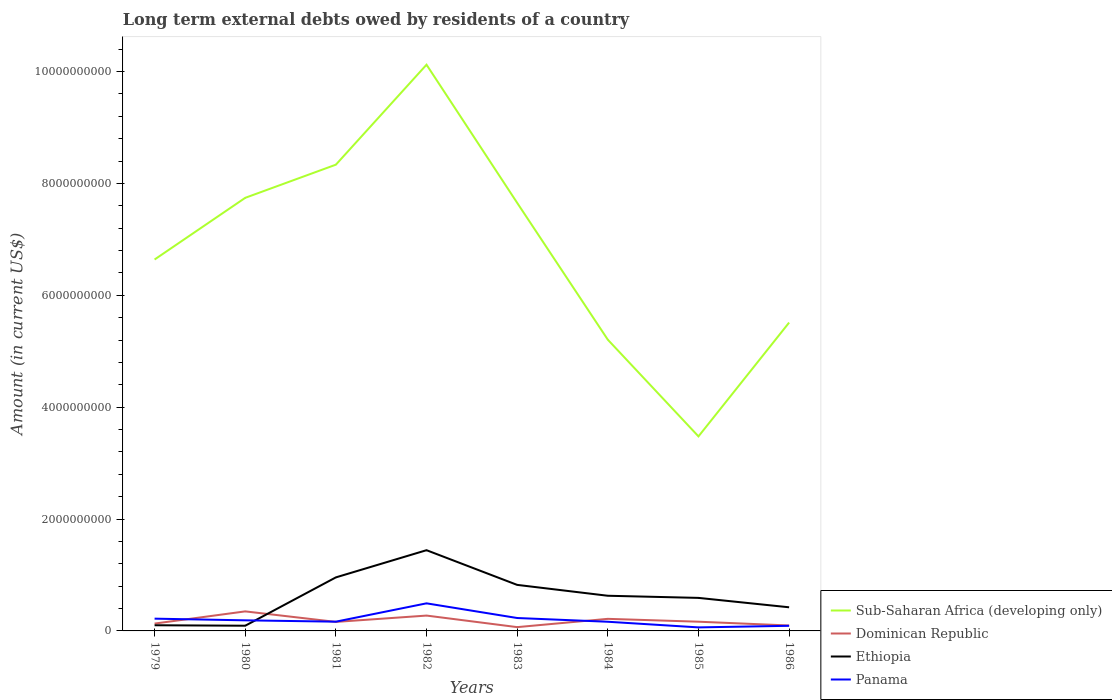Does the line corresponding to Dominican Republic intersect with the line corresponding to Sub-Saharan Africa (developing only)?
Offer a very short reply. No. Across all years, what is the maximum amount of long-term external debts owed by residents in Panama?
Your answer should be very brief. 6.31e+07. In which year was the amount of long-term external debts owed by residents in Dominican Republic maximum?
Offer a very short reply. 1983. What is the total amount of long-term external debts owed by residents in Dominican Republic in the graph?
Your response must be concise. 1.77e+08. What is the difference between the highest and the second highest amount of long-term external debts owed by residents in Sub-Saharan Africa (developing only)?
Keep it short and to the point. 6.64e+09. What is the difference between the highest and the lowest amount of long-term external debts owed by residents in Sub-Saharan Africa (developing only)?
Ensure brevity in your answer.  4. How many lines are there?
Offer a very short reply. 4. Does the graph contain any zero values?
Make the answer very short. No. Does the graph contain grids?
Your answer should be compact. No. How many legend labels are there?
Your response must be concise. 4. What is the title of the graph?
Your answer should be compact. Long term external debts owed by residents of a country. What is the Amount (in current US$) in Sub-Saharan Africa (developing only) in 1979?
Ensure brevity in your answer.  6.64e+09. What is the Amount (in current US$) in Dominican Republic in 1979?
Provide a succinct answer. 1.31e+08. What is the Amount (in current US$) in Ethiopia in 1979?
Ensure brevity in your answer.  1.01e+08. What is the Amount (in current US$) in Panama in 1979?
Offer a terse response. 2.19e+08. What is the Amount (in current US$) in Sub-Saharan Africa (developing only) in 1980?
Make the answer very short. 7.74e+09. What is the Amount (in current US$) of Dominican Republic in 1980?
Your response must be concise. 3.49e+08. What is the Amount (in current US$) of Ethiopia in 1980?
Keep it short and to the point. 9.30e+07. What is the Amount (in current US$) in Panama in 1980?
Your response must be concise. 1.89e+08. What is the Amount (in current US$) of Sub-Saharan Africa (developing only) in 1981?
Ensure brevity in your answer.  8.34e+09. What is the Amount (in current US$) in Dominican Republic in 1981?
Your answer should be compact. 1.61e+08. What is the Amount (in current US$) in Ethiopia in 1981?
Your answer should be compact. 9.57e+08. What is the Amount (in current US$) of Panama in 1981?
Your answer should be very brief. 1.65e+08. What is the Amount (in current US$) of Sub-Saharan Africa (developing only) in 1982?
Your response must be concise. 1.01e+1. What is the Amount (in current US$) in Dominican Republic in 1982?
Provide a succinct answer. 2.74e+08. What is the Amount (in current US$) of Ethiopia in 1982?
Make the answer very short. 1.44e+09. What is the Amount (in current US$) in Panama in 1982?
Offer a very short reply. 4.93e+08. What is the Amount (in current US$) of Sub-Saharan Africa (developing only) in 1983?
Offer a terse response. 7.65e+09. What is the Amount (in current US$) in Dominican Republic in 1983?
Provide a succinct answer. 6.77e+07. What is the Amount (in current US$) of Ethiopia in 1983?
Provide a short and direct response. 8.23e+08. What is the Amount (in current US$) of Panama in 1983?
Your response must be concise. 2.31e+08. What is the Amount (in current US$) in Sub-Saharan Africa (developing only) in 1984?
Offer a terse response. 5.21e+09. What is the Amount (in current US$) of Dominican Republic in 1984?
Give a very brief answer. 2.16e+08. What is the Amount (in current US$) in Ethiopia in 1984?
Your answer should be compact. 6.29e+08. What is the Amount (in current US$) in Panama in 1984?
Give a very brief answer. 1.64e+08. What is the Amount (in current US$) of Sub-Saharan Africa (developing only) in 1985?
Your answer should be compact. 3.48e+09. What is the Amount (in current US$) of Dominican Republic in 1985?
Provide a succinct answer. 1.65e+08. What is the Amount (in current US$) of Ethiopia in 1985?
Offer a very short reply. 5.91e+08. What is the Amount (in current US$) of Panama in 1985?
Provide a succinct answer. 6.31e+07. What is the Amount (in current US$) of Sub-Saharan Africa (developing only) in 1986?
Your answer should be compact. 5.51e+09. What is the Amount (in current US$) in Dominican Republic in 1986?
Provide a short and direct response. 9.71e+07. What is the Amount (in current US$) of Ethiopia in 1986?
Your response must be concise. 4.23e+08. What is the Amount (in current US$) in Panama in 1986?
Offer a terse response. 9.17e+07. Across all years, what is the maximum Amount (in current US$) of Sub-Saharan Africa (developing only)?
Make the answer very short. 1.01e+1. Across all years, what is the maximum Amount (in current US$) in Dominican Republic?
Ensure brevity in your answer.  3.49e+08. Across all years, what is the maximum Amount (in current US$) in Ethiopia?
Your answer should be compact. 1.44e+09. Across all years, what is the maximum Amount (in current US$) of Panama?
Ensure brevity in your answer.  4.93e+08. Across all years, what is the minimum Amount (in current US$) of Sub-Saharan Africa (developing only)?
Provide a succinct answer. 3.48e+09. Across all years, what is the minimum Amount (in current US$) in Dominican Republic?
Your answer should be very brief. 6.77e+07. Across all years, what is the minimum Amount (in current US$) of Ethiopia?
Offer a very short reply. 9.30e+07. Across all years, what is the minimum Amount (in current US$) of Panama?
Make the answer very short. 6.31e+07. What is the total Amount (in current US$) of Sub-Saharan Africa (developing only) in the graph?
Offer a terse response. 5.47e+1. What is the total Amount (in current US$) of Dominican Republic in the graph?
Ensure brevity in your answer.  1.46e+09. What is the total Amount (in current US$) in Ethiopia in the graph?
Offer a terse response. 5.06e+09. What is the total Amount (in current US$) of Panama in the graph?
Offer a terse response. 1.62e+09. What is the difference between the Amount (in current US$) of Sub-Saharan Africa (developing only) in 1979 and that in 1980?
Keep it short and to the point. -1.10e+09. What is the difference between the Amount (in current US$) of Dominican Republic in 1979 and that in 1980?
Ensure brevity in your answer.  -2.18e+08. What is the difference between the Amount (in current US$) of Ethiopia in 1979 and that in 1980?
Provide a succinct answer. 8.29e+06. What is the difference between the Amount (in current US$) in Panama in 1979 and that in 1980?
Ensure brevity in your answer.  3.00e+07. What is the difference between the Amount (in current US$) of Sub-Saharan Africa (developing only) in 1979 and that in 1981?
Provide a short and direct response. -1.70e+09. What is the difference between the Amount (in current US$) of Dominican Republic in 1979 and that in 1981?
Ensure brevity in your answer.  -3.00e+07. What is the difference between the Amount (in current US$) in Ethiopia in 1979 and that in 1981?
Make the answer very short. -8.56e+08. What is the difference between the Amount (in current US$) of Panama in 1979 and that in 1981?
Give a very brief answer. 5.39e+07. What is the difference between the Amount (in current US$) in Sub-Saharan Africa (developing only) in 1979 and that in 1982?
Offer a terse response. -3.48e+09. What is the difference between the Amount (in current US$) of Dominican Republic in 1979 and that in 1982?
Give a very brief answer. -1.43e+08. What is the difference between the Amount (in current US$) in Ethiopia in 1979 and that in 1982?
Your answer should be very brief. -1.34e+09. What is the difference between the Amount (in current US$) in Panama in 1979 and that in 1982?
Provide a succinct answer. -2.74e+08. What is the difference between the Amount (in current US$) of Sub-Saharan Africa (developing only) in 1979 and that in 1983?
Keep it short and to the point. -1.01e+09. What is the difference between the Amount (in current US$) in Dominican Republic in 1979 and that in 1983?
Give a very brief answer. 6.35e+07. What is the difference between the Amount (in current US$) in Ethiopia in 1979 and that in 1983?
Offer a terse response. -7.22e+08. What is the difference between the Amount (in current US$) of Panama in 1979 and that in 1983?
Provide a short and direct response. -1.15e+07. What is the difference between the Amount (in current US$) in Sub-Saharan Africa (developing only) in 1979 and that in 1984?
Your response must be concise. 1.43e+09. What is the difference between the Amount (in current US$) of Dominican Republic in 1979 and that in 1984?
Make the answer very short. -8.48e+07. What is the difference between the Amount (in current US$) of Ethiopia in 1979 and that in 1984?
Provide a short and direct response. -5.27e+08. What is the difference between the Amount (in current US$) of Panama in 1979 and that in 1984?
Keep it short and to the point. 5.54e+07. What is the difference between the Amount (in current US$) in Sub-Saharan Africa (developing only) in 1979 and that in 1985?
Your response must be concise. 3.16e+09. What is the difference between the Amount (in current US$) of Dominican Republic in 1979 and that in 1985?
Keep it short and to the point. -3.37e+07. What is the difference between the Amount (in current US$) of Ethiopia in 1979 and that in 1985?
Keep it short and to the point. -4.89e+08. What is the difference between the Amount (in current US$) of Panama in 1979 and that in 1985?
Ensure brevity in your answer.  1.56e+08. What is the difference between the Amount (in current US$) of Sub-Saharan Africa (developing only) in 1979 and that in 1986?
Offer a terse response. 1.13e+09. What is the difference between the Amount (in current US$) of Dominican Republic in 1979 and that in 1986?
Offer a very short reply. 3.41e+07. What is the difference between the Amount (in current US$) of Ethiopia in 1979 and that in 1986?
Keep it short and to the point. -3.21e+08. What is the difference between the Amount (in current US$) of Panama in 1979 and that in 1986?
Your answer should be very brief. 1.28e+08. What is the difference between the Amount (in current US$) in Sub-Saharan Africa (developing only) in 1980 and that in 1981?
Your response must be concise. -5.93e+08. What is the difference between the Amount (in current US$) of Dominican Republic in 1980 and that in 1981?
Offer a very short reply. 1.88e+08. What is the difference between the Amount (in current US$) in Ethiopia in 1980 and that in 1981?
Your response must be concise. -8.64e+08. What is the difference between the Amount (in current US$) in Panama in 1980 and that in 1981?
Provide a succinct answer. 2.39e+07. What is the difference between the Amount (in current US$) in Sub-Saharan Africa (developing only) in 1980 and that in 1982?
Your answer should be very brief. -2.38e+09. What is the difference between the Amount (in current US$) of Dominican Republic in 1980 and that in 1982?
Make the answer very short. 7.50e+07. What is the difference between the Amount (in current US$) of Ethiopia in 1980 and that in 1982?
Provide a short and direct response. -1.35e+09. What is the difference between the Amount (in current US$) of Panama in 1980 and that in 1982?
Your answer should be very brief. -3.04e+08. What is the difference between the Amount (in current US$) in Sub-Saharan Africa (developing only) in 1980 and that in 1983?
Your response must be concise. 8.99e+07. What is the difference between the Amount (in current US$) in Dominican Republic in 1980 and that in 1983?
Your answer should be very brief. 2.82e+08. What is the difference between the Amount (in current US$) of Ethiopia in 1980 and that in 1983?
Offer a terse response. -7.30e+08. What is the difference between the Amount (in current US$) in Panama in 1980 and that in 1983?
Offer a very short reply. -4.15e+07. What is the difference between the Amount (in current US$) of Sub-Saharan Africa (developing only) in 1980 and that in 1984?
Make the answer very short. 2.54e+09. What is the difference between the Amount (in current US$) in Dominican Republic in 1980 and that in 1984?
Offer a very short reply. 1.33e+08. What is the difference between the Amount (in current US$) in Ethiopia in 1980 and that in 1984?
Keep it short and to the point. -5.36e+08. What is the difference between the Amount (in current US$) of Panama in 1980 and that in 1984?
Offer a very short reply. 2.53e+07. What is the difference between the Amount (in current US$) in Sub-Saharan Africa (developing only) in 1980 and that in 1985?
Your response must be concise. 4.26e+09. What is the difference between the Amount (in current US$) of Dominican Republic in 1980 and that in 1985?
Your response must be concise. 1.84e+08. What is the difference between the Amount (in current US$) in Ethiopia in 1980 and that in 1985?
Ensure brevity in your answer.  -4.98e+08. What is the difference between the Amount (in current US$) in Panama in 1980 and that in 1985?
Provide a short and direct response. 1.26e+08. What is the difference between the Amount (in current US$) in Sub-Saharan Africa (developing only) in 1980 and that in 1986?
Offer a very short reply. 2.23e+09. What is the difference between the Amount (in current US$) of Dominican Republic in 1980 and that in 1986?
Offer a very short reply. 2.52e+08. What is the difference between the Amount (in current US$) of Ethiopia in 1980 and that in 1986?
Give a very brief answer. -3.30e+08. What is the difference between the Amount (in current US$) of Panama in 1980 and that in 1986?
Ensure brevity in your answer.  9.76e+07. What is the difference between the Amount (in current US$) in Sub-Saharan Africa (developing only) in 1981 and that in 1982?
Make the answer very short. -1.79e+09. What is the difference between the Amount (in current US$) of Dominican Republic in 1981 and that in 1982?
Give a very brief answer. -1.13e+08. What is the difference between the Amount (in current US$) of Ethiopia in 1981 and that in 1982?
Ensure brevity in your answer.  -4.86e+08. What is the difference between the Amount (in current US$) in Panama in 1981 and that in 1982?
Your answer should be compact. -3.28e+08. What is the difference between the Amount (in current US$) of Sub-Saharan Africa (developing only) in 1981 and that in 1983?
Make the answer very short. 6.83e+08. What is the difference between the Amount (in current US$) of Dominican Republic in 1981 and that in 1983?
Keep it short and to the point. 9.35e+07. What is the difference between the Amount (in current US$) in Ethiopia in 1981 and that in 1983?
Offer a very short reply. 1.34e+08. What is the difference between the Amount (in current US$) in Panama in 1981 and that in 1983?
Keep it short and to the point. -6.54e+07. What is the difference between the Amount (in current US$) of Sub-Saharan Africa (developing only) in 1981 and that in 1984?
Your response must be concise. 3.13e+09. What is the difference between the Amount (in current US$) in Dominican Republic in 1981 and that in 1984?
Offer a terse response. -5.48e+07. What is the difference between the Amount (in current US$) of Ethiopia in 1981 and that in 1984?
Make the answer very short. 3.28e+08. What is the difference between the Amount (in current US$) of Panama in 1981 and that in 1984?
Keep it short and to the point. 1.44e+06. What is the difference between the Amount (in current US$) in Sub-Saharan Africa (developing only) in 1981 and that in 1985?
Provide a short and direct response. 4.86e+09. What is the difference between the Amount (in current US$) of Dominican Republic in 1981 and that in 1985?
Keep it short and to the point. -3.71e+06. What is the difference between the Amount (in current US$) of Ethiopia in 1981 and that in 1985?
Your answer should be compact. 3.67e+08. What is the difference between the Amount (in current US$) of Panama in 1981 and that in 1985?
Your answer should be compact. 1.02e+08. What is the difference between the Amount (in current US$) of Sub-Saharan Africa (developing only) in 1981 and that in 1986?
Offer a terse response. 2.82e+09. What is the difference between the Amount (in current US$) in Dominican Republic in 1981 and that in 1986?
Provide a short and direct response. 6.41e+07. What is the difference between the Amount (in current US$) of Ethiopia in 1981 and that in 1986?
Give a very brief answer. 5.35e+08. What is the difference between the Amount (in current US$) in Panama in 1981 and that in 1986?
Your answer should be compact. 7.37e+07. What is the difference between the Amount (in current US$) of Sub-Saharan Africa (developing only) in 1982 and that in 1983?
Your answer should be compact. 2.47e+09. What is the difference between the Amount (in current US$) of Dominican Republic in 1982 and that in 1983?
Your answer should be very brief. 2.07e+08. What is the difference between the Amount (in current US$) in Ethiopia in 1982 and that in 1983?
Offer a terse response. 6.20e+08. What is the difference between the Amount (in current US$) in Panama in 1982 and that in 1983?
Provide a succinct answer. 2.62e+08. What is the difference between the Amount (in current US$) of Sub-Saharan Africa (developing only) in 1982 and that in 1984?
Make the answer very short. 4.92e+09. What is the difference between the Amount (in current US$) in Dominican Republic in 1982 and that in 1984?
Offer a very short reply. 5.84e+07. What is the difference between the Amount (in current US$) of Ethiopia in 1982 and that in 1984?
Provide a succinct answer. 8.14e+08. What is the difference between the Amount (in current US$) of Panama in 1982 and that in 1984?
Your answer should be compact. 3.29e+08. What is the difference between the Amount (in current US$) in Sub-Saharan Africa (developing only) in 1982 and that in 1985?
Offer a very short reply. 6.64e+09. What is the difference between the Amount (in current US$) of Dominican Republic in 1982 and that in 1985?
Ensure brevity in your answer.  1.09e+08. What is the difference between the Amount (in current US$) in Ethiopia in 1982 and that in 1985?
Provide a succinct answer. 8.53e+08. What is the difference between the Amount (in current US$) of Panama in 1982 and that in 1985?
Give a very brief answer. 4.30e+08. What is the difference between the Amount (in current US$) in Sub-Saharan Africa (developing only) in 1982 and that in 1986?
Your response must be concise. 4.61e+09. What is the difference between the Amount (in current US$) in Dominican Republic in 1982 and that in 1986?
Offer a very short reply. 1.77e+08. What is the difference between the Amount (in current US$) in Ethiopia in 1982 and that in 1986?
Provide a succinct answer. 1.02e+09. What is the difference between the Amount (in current US$) of Panama in 1982 and that in 1986?
Keep it short and to the point. 4.01e+08. What is the difference between the Amount (in current US$) in Sub-Saharan Africa (developing only) in 1983 and that in 1984?
Offer a very short reply. 2.45e+09. What is the difference between the Amount (in current US$) in Dominican Republic in 1983 and that in 1984?
Ensure brevity in your answer.  -1.48e+08. What is the difference between the Amount (in current US$) in Ethiopia in 1983 and that in 1984?
Offer a terse response. 1.94e+08. What is the difference between the Amount (in current US$) in Panama in 1983 and that in 1984?
Ensure brevity in your answer.  6.69e+07. What is the difference between the Amount (in current US$) in Sub-Saharan Africa (developing only) in 1983 and that in 1985?
Make the answer very short. 4.17e+09. What is the difference between the Amount (in current US$) of Dominican Republic in 1983 and that in 1985?
Offer a terse response. -9.72e+07. What is the difference between the Amount (in current US$) in Ethiopia in 1983 and that in 1985?
Provide a succinct answer. 2.32e+08. What is the difference between the Amount (in current US$) in Panama in 1983 and that in 1985?
Your response must be concise. 1.68e+08. What is the difference between the Amount (in current US$) of Sub-Saharan Africa (developing only) in 1983 and that in 1986?
Offer a terse response. 2.14e+09. What is the difference between the Amount (in current US$) in Dominican Republic in 1983 and that in 1986?
Your response must be concise. -2.94e+07. What is the difference between the Amount (in current US$) of Ethiopia in 1983 and that in 1986?
Keep it short and to the point. 4.00e+08. What is the difference between the Amount (in current US$) of Panama in 1983 and that in 1986?
Make the answer very short. 1.39e+08. What is the difference between the Amount (in current US$) in Sub-Saharan Africa (developing only) in 1984 and that in 1985?
Your answer should be compact. 1.73e+09. What is the difference between the Amount (in current US$) of Dominican Republic in 1984 and that in 1985?
Your response must be concise. 5.11e+07. What is the difference between the Amount (in current US$) in Ethiopia in 1984 and that in 1985?
Your answer should be compact. 3.82e+07. What is the difference between the Amount (in current US$) in Panama in 1984 and that in 1985?
Offer a terse response. 1.01e+08. What is the difference between the Amount (in current US$) in Sub-Saharan Africa (developing only) in 1984 and that in 1986?
Provide a succinct answer. -3.06e+08. What is the difference between the Amount (in current US$) in Dominican Republic in 1984 and that in 1986?
Offer a terse response. 1.19e+08. What is the difference between the Amount (in current US$) of Ethiopia in 1984 and that in 1986?
Your answer should be compact. 2.06e+08. What is the difference between the Amount (in current US$) of Panama in 1984 and that in 1986?
Your answer should be very brief. 7.23e+07. What is the difference between the Amount (in current US$) of Sub-Saharan Africa (developing only) in 1985 and that in 1986?
Offer a very short reply. -2.03e+09. What is the difference between the Amount (in current US$) of Dominican Republic in 1985 and that in 1986?
Keep it short and to the point. 6.78e+07. What is the difference between the Amount (in current US$) in Ethiopia in 1985 and that in 1986?
Make the answer very short. 1.68e+08. What is the difference between the Amount (in current US$) of Panama in 1985 and that in 1986?
Offer a very short reply. -2.86e+07. What is the difference between the Amount (in current US$) of Sub-Saharan Africa (developing only) in 1979 and the Amount (in current US$) of Dominican Republic in 1980?
Offer a terse response. 6.29e+09. What is the difference between the Amount (in current US$) of Sub-Saharan Africa (developing only) in 1979 and the Amount (in current US$) of Ethiopia in 1980?
Your answer should be compact. 6.55e+09. What is the difference between the Amount (in current US$) in Sub-Saharan Africa (developing only) in 1979 and the Amount (in current US$) in Panama in 1980?
Make the answer very short. 6.45e+09. What is the difference between the Amount (in current US$) in Dominican Republic in 1979 and the Amount (in current US$) in Ethiopia in 1980?
Your response must be concise. 3.82e+07. What is the difference between the Amount (in current US$) of Dominican Republic in 1979 and the Amount (in current US$) of Panama in 1980?
Ensure brevity in your answer.  -5.81e+07. What is the difference between the Amount (in current US$) in Ethiopia in 1979 and the Amount (in current US$) in Panama in 1980?
Provide a succinct answer. -8.80e+07. What is the difference between the Amount (in current US$) in Sub-Saharan Africa (developing only) in 1979 and the Amount (in current US$) in Dominican Republic in 1981?
Provide a succinct answer. 6.48e+09. What is the difference between the Amount (in current US$) in Sub-Saharan Africa (developing only) in 1979 and the Amount (in current US$) in Ethiopia in 1981?
Your answer should be very brief. 5.68e+09. What is the difference between the Amount (in current US$) in Sub-Saharan Africa (developing only) in 1979 and the Amount (in current US$) in Panama in 1981?
Give a very brief answer. 6.47e+09. What is the difference between the Amount (in current US$) in Dominican Republic in 1979 and the Amount (in current US$) in Ethiopia in 1981?
Give a very brief answer. -8.26e+08. What is the difference between the Amount (in current US$) in Dominican Republic in 1979 and the Amount (in current US$) in Panama in 1981?
Offer a very short reply. -3.42e+07. What is the difference between the Amount (in current US$) of Ethiopia in 1979 and the Amount (in current US$) of Panama in 1981?
Make the answer very short. -6.41e+07. What is the difference between the Amount (in current US$) in Sub-Saharan Africa (developing only) in 1979 and the Amount (in current US$) in Dominican Republic in 1982?
Your answer should be compact. 6.37e+09. What is the difference between the Amount (in current US$) of Sub-Saharan Africa (developing only) in 1979 and the Amount (in current US$) of Ethiopia in 1982?
Your response must be concise. 5.20e+09. What is the difference between the Amount (in current US$) in Sub-Saharan Africa (developing only) in 1979 and the Amount (in current US$) in Panama in 1982?
Offer a terse response. 6.15e+09. What is the difference between the Amount (in current US$) of Dominican Republic in 1979 and the Amount (in current US$) of Ethiopia in 1982?
Offer a terse response. -1.31e+09. What is the difference between the Amount (in current US$) in Dominican Republic in 1979 and the Amount (in current US$) in Panama in 1982?
Provide a succinct answer. -3.62e+08. What is the difference between the Amount (in current US$) in Ethiopia in 1979 and the Amount (in current US$) in Panama in 1982?
Give a very brief answer. -3.92e+08. What is the difference between the Amount (in current US$) in Sub-Saharan Africa (developing only) in 1979 and the Amount (in current US$) in Dominican Republic in 1983?
Offer a very short reply. 6.57e+09. What is the difference between the Amount (in current US$) of Sub-Saharan Africa (developing only) in 1979 and the Amount (in current US$) of Ethiopia in 1983?
Your answer should be compact. 5.82e+09. What is the difference between the Amount (in current US$) in Sub-Saharan Africa (developing only) in 1979 and the Amount (in current US$) in Panama in 1983?
Provide a succinct answer. 6.41e+09. What is the difference between the Amount (in current US$) in Dominican Republic in 1979 and the Amount (in current US$) in Ethiopia in 1983?
Keep it short and to the point. -6.92e+08. What is the difference between the Amount (in current US$) in Dominican Republic in 1979 and the Amount (in current US$) in Panama in 1983?
Offer a very short reply. -9.96e+07. What is the difference between the Amount (in current US$) of Ethiopia in 1979 and the Amount (in current US$) of Panama in 1983?
Your answer should be compact. -1.30e+08. What is the difference between the Amount (in current US$) of Sub-Saharan Africa (developing only) in 1979 and the Amount (in current US$) of Dominican Republic in 1984?
Your answer should be very brief. 6.42e+09. What is the difference between the Amount (in current US$) of Sub-Saharan Africa (developing only) in 1979 and the Amount (in current US$) of Ethiopia in 1984?
Provide a short and direct response. 6.01e+09. What is the difference between the Amount (in current US$) in Sub-Saharan Africa (developing only) in 1979 and the Amount (in current US$) in Panama in 1984?
Offer a very short reply. 6.48e+09. What is the difference between the Amount (in current US$) in Dominican Republic in 1979 and the Amount (in current US$) in Ethiopia in 1984?
Your answer should be very brief. -4.98e+08. What is the difference between the Amount (in current US$) of Dominican Republic in 1979 and the Amount (in current US$) of Panama in 1984?
Keep it short and to the point. -3.28e+07. What is the difference between the Amount (in current US$) of Ethiopia in 1979 and the Amount (in current US$) of Panama in 1984?
Provide a succinct answer. -6.27e+07. What is the difference between the Amount (in current US$) of Sub-Saharan Africa (developing only) in 1979 and the Amount (in current US$) of Dominican Republic in 1985?
Give a very brief answer. 6.48e+09. What is the difference between the Amount (in current US$) in Sub-Saharan Africa (developing only) in 1979 and the Amount (in current US$) in Ethiopia in 1985?
Provide a short and direct response. 6.05e+09. What is the difference between the Amount (in current US$) of Sub-Saharan Africa (developing only) in 1979 and the Amount (in current US$) of Panama in 1985?
Provide a succinct answer. 6.58e+09. What is the difference between the Amount (in current US$) of Dominican Republic in 1979 and the Amount (in current US$) of Ethiopia in 1985?
Your response must be concise. -4.59e+08. What is the difference between the Amount (in current US$) of Dominican Republic in 1979 and the Amount (in current US$) of Panama in 1985?
Make the answer very short. 6.81e+07. What is the difference between the Amount (in current US$) of Ethiopia in 1979 and the Amount (in current US$) of Panama in 1985?
Offer a very short reply. 3.82e+07. What is the difference between the Amount (in current US$) of Sub-Saharan Africa (developing only) in 1979 and the Amount (in current US$) of Dominican Republic in 1986?
Offer a terse response. 6.54e+09. What is the difference between the Amount (in current US$) of Sub-Saharan Africa (developing only) in 1979 and the Amount (in current US$) of Ethiopia in 1986?
Offer a very short reply. 6.22e+09. What is the difference between the Amount (in current US$) of Sub-Saharan Africa (developing only) in 1979 and the Amount (in current US$) of Panama in 1986?
Your answer should be compact. 6.55e+09. What is the difference between the Amount (in current US$) in Dominican Republic in 1979 and the Amount (in current US$) in Ethiopia in 1986?
Make the answer very short. -2.91e+08. What is the difference between the Amount (in current US$) of Dominican Republic in 1979 and the Amount (in current US$) of Panama in 1986?
Your response must be concise. 3.95e+07. What is the difference between the Amount (in current US$) in Ethiopia in 1979 and the Amount (in current US$) in Panama in 1986?
Provide a succinct answer. 9.62e+06. What is the difference between the Amount (in current US$) in Sub-Saharan Africa (developing only) in 1980 and the Amount (in current US$) in Dominican Republic in 1981?
Make the answer very short. 7.58e+09. What is the difference between the Amount (in current US$) of Sub-Saharan Africa (developing only) in 1980 and the Amount (in current US$) of Ethiopia in 1981?
Give a very brief answer. 6.79e+09. What is the difference between the Amount (in current US$) of Sub-Saharan Africa (developing only) in 1980 and the Amount (in current US$) of Panama in 1981?
Offer a very short reply. 7.58e+09. What is the difference between the Amount (in current US$) in Dominican Republic in 1980 and the Amount (in current US$) in Ethiopia in 1981?
Your answer should be very brief. -6.08e+08. What is the difference between the Amount (in current US$) in Dominican Republic in 1980 and the Amount (in current US$) in Panama in 1981?
Make the answer very short. 1.84e+08. What is the difference between the Amount (in current US$) in Ethiopia in 1980 and the Amount (in current US$) in Panama in 1981?
Ensure brevity in your answer.  -7.24e+07. What is the difference between the Amount (in current US$) of Sub-Saharan Africa (developing only) in 1980 and the Amount (in current US$) of Dominican Republic in 1982?
Your answer should be very brief. 7.47e+09. What is the difference between the Amount (in current US$) of Sub-Saharan Africa (developing only) in 1980 and the Amount (in current US$) of Ethiopia in 1982?
Offer a terse response. 6.30e+09. What is the difference between the Amount (in current US$) in Sub-Saharan Africa (developing only) in 1980 and the Amount (in current US$) in Panama in 1982?
Provide a short and direct response. 7.25e+09. What is the difference between the Amount (in current US$) in Dominican Republic in 1980 and the Amount (in current US$) in Ethiopia in 1982?
Make the answer very short. -1.09e+09. What is the difference between the Amount (in current US$) of Dominican Republic in 1980 and the Amount (in current US$) of Panama in 1982?
Keep it short and to the point. -1.44e+08. What is the difference between the Amount (in current US$) in Ethiopia in 1980 and the Amount (in current US$) in Panama in 1982?
Keep it short and to the point. -4.00e+08. What is the difference between the Amount (in current US$) of Sub-Saharan Africa (developing only) in 1980 and the Amount (in current US$) of Dominican Republic in 1983?
Give a very brief answer. 7.68e+09. What is the difference between the Amount (in current US$) in Sub-Saharan Africa (developing only) in 1980 and the Amount (in current US$) in Ethiopia in 1983?
Offer a very short reply. 6.92e+09. What is the difference between the Amount (in current US$) of Sub-Saharan Africa (developing only) in 1980 and the Amount (in current US$) of Panama in 1983?
Your response must be concise. 7.51e+09. What is the difference between the Amount (in current US$) in Dominican Republic in 1980 and the Amount (in current US$) in Ethiopia in 1983?
Offer a very short reply. -4.74e+08. What is the difference between the Amount (in current US$) of Dominican Republic in 1980 and the Amount (in current US$) of Panama in 1983?
Your answer should be very brief. 1.19e+08. What is the difference between the Amount (in current US$) in Ethiopia in 1980 and the Amount (in current US$) in Panama in 1983?
Your response must be concise. -1.38e+08. What is the difference between the Amount (in current US$) of Sub-Saharan Africa (developing only) in 1980 and the Amount (in current US$) of Dominican Republic in 1984?
Offer a terse response. 7.53e+09. What is the difference between the Amount (in current US$) in Sub-Saharan Africa (developing only) in 1980 and the Amount (in current US$) in Ethiopia in 1984?
Offer a very short reply. 7.11e+09. What is the difference between the Amount (in current US$) of Sub-Saharan Africa (developing only) in 1980 and the Amount (in current US$) of Panama in 1984?
Your answer should be very brief. 7.58e+09. What is the difference between the Amount (in current US$) in Dominican Republic in 1980 and the Amount (in current US$) in Ethiopia in 1984?
Your response must be concise. -2.79e+08. What is the difference between the Amount (in current US$) in Dominican Republic in 1980 and the Amount (in current US$) in Panama in 1984?
Ensure brevity in your answer.  1.85e+08. What is the difference between the Amount (in current US$) in Ethiopia in 1980 and the Amount (in current US$) in Panama in 1984?
Provide a short and direct response. -7.10e+07. What is the difference between the Amount (in current US$) of Sub-Saharan Africa (developing only) in 1980 and the Amount (in current US$) of Dominican Republic in 1985?
Ensure brevity in your answer.  7.58e+09. What is the difference between the Amount (in current US$) in Sub-Saharan Africa (developing only) in 1980 and the Amount (in current US$) in Ethiopia in 1985?
Provide a short and direct response. 7.15e+09. What is the difference between the Amount (in current US$) of Sub-Saharan Africa (developing only) in 1980 and the Amount (in current US$) of Panama in 1985?
Offer a very short reply. 7.68e+09. What is the difference between the Amount (in current US$) of Dominican Republic in 1980 and the Amount (in current US$) of Ethiopia in 1985?
Provide a short and direct response. -2.41e+08. What is the difference between the Amount (in current US$) of Dominican Republic in 1980 and the Amount (in current US$) of Panama in 1985?
Your answer should be very brief. 2.86e+08. What is the difference between the Amount (in current US$) in Ethiopia in 1980 and the Amount (in current US$) in Panama in 1985?
Keep it short and to the point. 2.99e+07. What is the difference between the Amount (in current US$) of Sub-Saharan Africa (developing only) in 1980 and the Amount (in current US$) of Dominican Republic in 1986?
Keep it short and to the point. 7.65e+09. What is the difference between the Amount (in current US$) in Sub-Saharan Africa (developing only) in 1980 and the Amount (in current US$) in Ethiopia in 1986?
Make the answer very short. 7.32e+09. What is the difference between the Amount (in current US$) of Sub-Saharan Africa (developing only) in 1980 and the Amount (in current US$) of Panama in 1986?
Your response must be concise. 7.65e+09. What is the difference between the Amount (in current US$) in Dominican Republic in 1980 and the Amount (in current US$) in Ethiopia in 1986?
Ensure brevity in your answer.  -7.32e+07. What is the difference between the Amount (in current US$) of Dominican Republic in 1980 and the Amount (in current US$) of Panama in 1986?
Your answer should be very brief. 2.58e+08. What is the difference between the Amount (in current US$) of Ethiopia in 1980 and the Amount (in current US$) of Panama in 1986?
Your answer should be very brief. 1.33e+06. What is the difference between the Amount (in current US$) in Sub-Saharan Africa (developing only) in 1981 and the Amount (in current US$) in Dominican Republic in 1982?
Offer a very short reply. 8.06e+09. What is the difference between the Amount (in current US$) of Sub-Saharan Africa (developing only) in 1981 and the Amount (in current US$) of Ethiopia in 1982?
Give a very brief answer. 6.89e+09. What is the difference between the Amount (in current US$) of Sub-Saharan Africa (developing only) in 1981 and the Amount (in current US$) of Panama in 1982?
Keep it short and to the point. 7.84e+09. What is the difference between the Amount (in current US$) in Dominican Republic in 1981 and the Amount (in current US$) in Ethiopia in 1982?
Give a very brief answer. -1.28e+09. What is the difference between the Amount (in current US$) in Dominican Republic in 1981 and the Amount (in current US$) in Panama in 1982?
Make the answer very short. -3.32e+08. What is the difference between the Amount (in current US$) in Ethiopia in 1981 and the Amount (in current US$) in Panama in 1982?
Offer a very short reply. 4.64e+08. What is the difference between the Amount (in current US$) of Sub-Saharan Africa (developing only) in 1981 and the Amount (in current US$) of Dominican Republic in 1983?
Give a very brief answer. 8.27e+09. What is the difference between the Amount (in current US$) in Sub-Saharan Africa (developing only) in 1981 and the Amount (in current US$) in Ethiopia in 1983?
Make the answer very short. 7.51e+09. What is the difference between the Amount (in current US$) of Sub-Saharan Africa (developing only) in 1981 and the Amount (in current US$) of Panama in 1983?
Provide a short and direct response. 8.10e+09. What is the difference between the Amount (in current US$) of Dominican Republic in 1981 and the Amount (in current US$) of Ethiopia in 1983?
Provide a succinct answer. -6.62e+08. What is the difference between the Amount (in current US$) of Dominican Republic in 1981 and the Amount (in current US$) of Panama in 1983?
Your response must be concise. -6.96e+07. What is the difference between the Amount (in current US$) in Ethiopia in 1981 and the Amount (in current US$) in Panama in 1983?
Your answer should be compact. 7.26e+08. What is the difference between the Amount (in current US$) in Sub-Saharan Africa (developing only) in 1981 and the Amount (in current US$) in Dominican Republic in 1984?
Keep it short and to the point. 8.12e+09. What is the difference between the Amount (in current US$) in Sub-Saharan Africa (developing only) in 1981 and the Amount (in current US$) in Ethiopia in 1984?
Make the answer very short. 7.71e+09. What is the difference between the Amount (in current US$) of Sub-Saharan Africa (developing only) in 1981 and the Amount (in current US$) of Panama in 1984?
Provide a succinct answer. 8.17e+09. What is the difference between the Amount (in current US$) in Dominican Republic in 1981 and the Amount (in current US$) in Ethiopia in 1984?
Offer a terse response. -4.68e+08. What is the difference between the Amount (in current US$) in Dominican Republic in 1981 and the Amount (in current US$) in Panama in 1984?
Provide a succinct answer. -2.75e+06. What is the difference between the Amount (in current US$) in Ethiopia in 1981 and the Amount (in current US$) in Panama in 1984?
Your response must be concise. 7.93e+08. What is the difference between the Amount (in current US$) in Sub-Saharan Africa (developing only) in 1981 and the Amount (in current US$) in Dominican Republic in 1985?
Offer a terse response. 8.17e+09. What is the difference between the Amount (in current US$) of Sub-Saharan Africa (developing only) in 1981 and the Amount (in current US$) of Ethiopia in 1985?
Make the answer very short. 7.74e+09. What is the difference between the Amount (in current US$) in Sub-Saharan Africa (developing only) in 1981 and the Amount (in current US$) in Panama in 1985?
Ensure brevity in your answer.  8.27e+09. What is the difference between the Amount (in current US$) in Dominican Republic in 1981 and the Amount (in current US$) in Ethiopia in 1985?
Offer a terse response. -4.29e+08. What is the difference between the Amount (in current US$) of Dominican Republic in 1981 and the Amount (in current US$) of Panama in 1985?
Keep it short and to the point. 9.81e+07. What is the difference between the Amount (in current US$) in Ethiopia in 1981 and the Amount (in current US$) in Panama in 1985?
Offer a terse response. 8.94e+08. What is the difference between the Amount (in current US$) in Sub-Saharan Africa (developing only) in 1981 and the Amount (in current US$) in Dominican Republic in 1986?
Your answer should be compact. 8.24e+09. What is the difference between the Amount (in current US$) in Sub-Saharan Africa (developing only) in 1981 and the Amount (in current US$) in Ethiopia in 1986?
Provide a succinct answer. 7.91e+09. What is the difference between the Amount (in current US$) in Sub-Saharan Africa (developing only) in 1981 and the Amount (in current US$) in Panama in 1986?
Ensure brevity in your answer.  8.24e+09. What is the difference between the Amount (in current US$) of Dominican Republic in 1981 and the Amount (in current US$) of Ethiopia in 1986?
Make the answer very short. -2.61e+08. What is the difference between the Amount (in current US$) of Dominican Republic in 1981 and the Amount (in current US$) of Panama in 1986?
Offer a terse response. 6.96e+07. What is the difference between the Amount (in current US$) of Ethiopia in 1981 and the Amount (in current US$) of Panama in 1986?
Keep it short and to the point. 8.65e+08. What is the difference between the Amount (in current US$) of Sub-Saharan Africa (developing only) in 1982 and the Amount (in current US$) of Dominican Republic in 1983?
Provide a short and direct response. 1.01e+1. What is the difference between the Amount (in current US$) in Sub-Saharan Africa (developing only) in 1982 and the Amount (in current US$) in Ethiopia in 1983?
Offer a terse response. 9.30e+09. What is the difference between the Amount (in current US$) of Sub-Saharan Africa (developing only) in 1982 and the Amount (in current US$) of Panama in 1983?
Your response must be concise. 9.89e+09. What is the difference between the Amount (in current US$) in Dominican Republic in 1982 and the Amount (in current US$) in Ethiopia in 1983?
Keep it short and to the point. -5.49e+08. What is the difference between the Amount (in current US$) of Dominican Republic in 1982 and the Amount (in current US$) of Panama in 1983?
Offer a very short reply. 4.36e+07. What is the difference between the Amount (in current US$) in Ethiopia in 1982 and the Amount (in current US$) in Panama in 1983?
Give a very brief answer. 1.21e+09. What is the difference between the Amount (in current US$) in Sub-Saharan Africa (developing only) in 1982 and the Amount (in current US$) in Dominican Republic in 1984?
Provide a succinct answer. 9.91e+09. What is the difference between the Amount (in current US$) in Sub-Saharan Africa (developing only) in 1982 and the Amount (in current US$) in Ethiopia in 1984?
Ensure brevity in your answer.  9.49e+09. What is the difference between the Amount (in current US$) of Sub-Saharan Africa (developing only) in 1982 and the Amount (in current US$) of Panama in 1984?
Provide a succinct answer. 9.96e+09. What is the difference between the Amount (in current US$) in Dominican Republic in 1982 and the Amount (in current US$) in Ethiopia in 1984?
Offer a very short reply. -3.54e+08. What is the difference between the Amount (in current US$) in Dominican Republic in 1982 and the Amount (in current US$) in Panama in 1984?
Provide a short and direct response. 1.10e+08. What is the difference between the Amount (in current US$) of Ethiopia in 1982 and the Amount (in current US$) of Panama in 1984?
Provide a succinct answer. 1.28e+09. What is the difference between the Amount (in current US$) in Sub-Saharan Africa (developing only) in 1982 and the Amount (in current US$) in Dominican Republic in 1985?
Provide a short and direct response. 9.96e+09. What is the difference between the Amount (in current US$) in Sub-Saharan Africa (developing only) in 1982 and the Amount (in current US$) in Ethiopia in 1985?
Ensure brevity in your answer.  9.53e+09. What is the difference between the Amount (in current US$) in Sub-Saharan Africa (developing only) in 1982 and the Amount (in current US$) in Panama in 1985?
Ensure brevity in your answer.  1.01e+1. What is the difference between the Amount (in current US$) of Dominican Republic in 1982 and the Amount (in current US$) of Ethiopia in 1985?
Your response must be concise. -3.16e+08. What is the difference between the Amount (in current US$) in Dominican Republic in 1982 and the Amount (in current US$) in Panama in 1985?
Offer a terse response. 2.11e+08. What is the difference between the Amount (in current US$) in Ethiopia in 1982 and the Amount (in current US$) in Panama in 1985?
Keep it short and to the point. 1.38e+09. What is the difference between the Amount (in current US$) of Sub-Saharan Africa (developing only) in 1982 and the Amount (in current US$) of Dominican Republic in 1986?
Ensure brevity in your answer.  1.00e+1. What is the difference between the Amount (in current US$) in Sub-Saharan Africa (developing only) in 1982 and the Amount (in current US$) in Ethiopia in 1986?
Your answer should be compact. 9.70e+09. What is the difference between the Amount (in current US$) of Sub-Saharan Africa (developing only) in 1982 and the Amount (in current US$) of Panama in 1986?
Your answer should be very brief. 1.00e+1. What is the difference between the Amount (in current US$) in Dominican Republic in 1982 and the Amount (in current US$) in Ethiopia in 1986?
Make the answer very short. -1.48e+08. What is the difference between the Amount (in current US$) in Dominican Republic in 1982 and the Amount (in current US$) in Panama in 1986?
Ensure brevity in your answer.  1.83e+08. What is the difference between the Amount (in current US$) of Ethiopia in 1982 and the Amount (in current US$) of Panama in 1986?
Your answer should be compact. 1.35e+09. What is the difference between the Amount (in current US$) of Sub-Saharan Africa (developing only) in 1983 and the Amount (in current US$) of Dominican Republic in 1984?
Provide a succinct answer. 7.44e+09. What is the difference between the Amount (in current US$) in Sub-Saharan Africa (developing only) in 1983 and the Amount (in current US$) in Ethiopia in 1984?
Provide a short and direct response. 7.02e+09. What is the difference between the Amount (in current US$) in Sub-Saharan Africa (developing only) in 1983 and the Amount (in current US$) in Panama in 1984?
Provide a succinct answer. 7.49e+09. What is the difference between the Amount (in current US$) of Dominican Republic in 1983 and the Amount (in current US$) of Ethiopia in 1984?
Offer a terse response. -5.61e+08. What is the difference between the Amount (in current US$) of Dominican Republic in 1983 and the Amount (in current US$) of Panama in 1984?
Offer a very short reply. -9.62e+07. What is the difference between the Amount (in current US$) of Ethiopia in 1983 and the Amount (in current US$) of Panama in 1984?
Your answer should be compact. 6.59e+08. What is the difference between the Amount (in current US$) of Sub-Saharan Africa (developing only) in 1983 and the Amount (in current US$) of Dominican Republic in 1985?
Give a very brief answer. 7.49e+09. What is the difference between the Amount (in current US$) of Sub-Saharan Africa (developing only) in 1983 and the Amount (in current US$) of Ethiopia in 1985?
Ensure brevity in your answer.  7.06e+09. What is the difference between the Amount (in current US$) of Sub-Saharan Africa (developing only) in 1983 and the Amount (in current US$) of Panama in 1985?
Offer a very short reply. 7.59e+09. What is the difference between the Amount (in current US$) in Dominican Republic in 1983 and the Amount (in current US$) in Ethiopia in 1985?
Offer a terse response. -5.23e+08. What is the difference between the Amount (in current US$) of Dominican Republic in 1983 and the Amount (in current US$) of Panama in 1985?
Your response must be concise. 4.62e+06. What is the difference between the Amount (in current US$) in Ethiopia in 1983 and the Amount (in current US$) in Panama in 1985?
Keep it short and to the point. 7.60e+08. What is the difference between the Amount (in current US$) of Sub-Saharan Africa (developing only) in 1983 and the Amount (in current US$) of Dominican Republic in 1986?
Provide a short and direct response. 7.56e+09. What is the difference between the Amount (in current US$) of Sub-Saharan Africa (developing only) in 1983 and the Amount (in current US$) of Ethiopia in 1986?
Your answer should be very brief. 7.23e+09. What is the difference between the Amount (in current US$) of Sub-Saharan Africa (developing only) in 1983 and the Amount (in current US$) of Panama in 1986?
Provide a succinct answer. 7.56e+09. What is the difference between the Amount (in current US$) of Dominican Republic in 1983 and the Amount (in current US$) of Ethiopia in 1986?
Keep it short and to the point. -3.55e+08. What is the difference between the Amount (in current US$) of Dominican Republic in 1983 and the Amount (in current US$) of Panama in 1986?
Keep it short and to the point. -2.39e+07. What is the difference between the Amount (in current US$) in Ethiopia in 1983 and the Amount (in current US$) in Panama in 1986?
Offer a terse response. 7.31e+08. What is the difference between the Amount (in current US$) of Sub-Saharan Africa (developing only) in 1984 and the Amount (in current US$) of Dominican Republic in 1985?
Your response must be concise. 5.04e+09. What is the difference between the Amount (in current US$) in Sub-Saharan Africa (developing only) in 1984 and the Amount (in current US$) in Ethiopia in 1985?
Provide a short and direct response. 4.62e+09. What is the difference between the Amount (in current US$) in Sub-Saharan Africa (developing only) in 1984 and the Amount (in current US$) in Panama in 1985?
Ensure brevity in your answer.  5.14e+09. What is the difference between the Amount (in current US$) in Dominican Republic in 1984 and the Amount (in current US$) in Ethiopia in 1985?
Give a very brief answer. -3.75e+08. What is the difference between the Amount (in current US$) in Dominican Republic in 1984 and the Amount (in current US$) in Panama in 1985?
Make the answer very short. 1.53e+08. What is the difference between the Amount (in current US$) of Ethiopia in 1984 and the Amount (in current US$) of Panama in 1985?
Your answer should be very brief. 5.66e+08. What is the difference between the Amount (in current US$) in Sub-Saharan Africa (developing only) in 1984 and the Amount (in current US$) in Dominican Republic in 1986?
Keep it short and to the point. 5.11e+09. What is the difference between the Amount (in current US$) in Sub-Saharan Africa (developing only) in 1984 and the Amount (in current US$) in Ethiopia in 1986?
Ensure brevity in your answer.  4.78e+09. What is the difference between the Amount (in current US$) in Sub-Saharan Africa (developing only) in 1984 and the Amount (in current US$) in Panama in 1986?
Your answer should be compact. 5.11e+09. What is the difference between the Amount (in current US$) of Dominican Republic in 1984 and the Amount (in current US$) of Ethiopia in 1986?
Provide a short and direct response. -2.06e+08. What is the difference between the Amount (in current US$) in Dominican Republic in 1984 and the Amount (in current US$) in Panama in 1986?
Offer a very short reply. 1.24e+08. What is the difference between the Amount (in current US$) of Ethiopia in 1984 and the Amount (in current US$) of Panama in 1986?
Offer a terse response. 5.37e+08. What is the difference between the Amount (in current US$) in Sub-Saharan Africa (developing only) in 1985 and the Amount (in current US$) in Dominican Republic in 1986?
Provide a succinct answer. 3.38e+09. What is the difference between the Amount (in current US$) in Sub-Saharan Africa (developing only) in 1985 and the Amount (in current US$) in Ethiopia in 1986?
Provide a succinct answer. 3.06e+09. What is the difference between the Amount (in current US$) in Sub-Saharan Africa (developing only) in 1985 and the Amount (in current US$) in Panama in 1986?
Offer a terse response. 3.39e+09. What is the difference between the Amount (in current US$) of Dominican Republic in 1985 and the Amount (in current US$) of Ethiopia in 1986?
Provide a short and direct response. -2.58e+08. What is the difference between the Amount (in current US$) in Dominican Republic in 1985 and the Amount (in current US$) in Panama in 1986?
Your response must be concise. 7.33e+07. What is the difference between the Amount (in current US$) of Ethiopia in 1985 and the Amount (in current US$) of Panama in 1986?
Offer a terse response. 4.99e+08. What is the average Amount (in current US$) in Sub-Saharan Africa (developing only) per year?
Provide a short and direct response. 6.84e+09. What is the average Amount (in current US$) in Dominican Republic per year?
Keep it short and to the point. 1.83e+08. What is the average Amount (in current US$) in Ethiopia per year?
Ensure brevity in your answer.  6.32e+08. What is the average Amount (in current US$) in Panama per year?
Ensure brevity in your answer.  2.02e+08. In the year 1979, what is the difference between the Amount (in current US$) in Sub-Saharan Africa (developing only) and Amount (in current US$) in Dominican Republic?
Your answer should be very brief. 6.51e+09. In the year 1979, what is the difference between the Amount (in current US$) in Sub-Saharan Africa (developing only) and Amount (in current US$) in Ethiopia?
Offer a very short reply. 6.54e+09. In the year 1979, what is the difference between the Amount (in current US$) in Sub-Saharan Africa (developing only) and Amount (in current US$) in Panama?
Make the answer very short. 6.42e+09. In the year 1979, what is the difference between the Amount (in current US$) in Dominican Republic and Amount (in current US$) in Ethiopia?
Ensure brevity in your answer.  2.99e+07. In the year 1979, what is the difference between the Amount (in current US$) of Dominican Republic and Amount (in current US$) of Panama?
Your response must be concise. -8.81e+07. In the year 1979, what is the difference between the Amount (in current US$) in Ethiopia and Amount (in current US$) in Panama?
Your response must be concise. -1.18e+08. In the year 1980, what is the difference between the Amount (in current US$) in Sub-Saharan Africa (developing only) and Amount (in current US$) in Dominican Republic?
Your answer should be very brief. 7.39e+09. In the year 1980, what is the difference between the Amount (in current US$) in Sub-Saharan Africa (developing only) and Amount (in current US$) in Ethiopia?
Your response must be concise. 7.65e+09. In the year 1980, what is the difference between the Amount (in current US$) of Sub-Saharan Africa (developing only) and Amount (in current US$) of Panama?
Ensure brevity in your answer.  7.55e+09. In the year 1980, what is the difference between the Amount (in current US$) in Dominican Republic and Amount (in current US$) in Ethiopia?
Provide a short and direct response. 2.56e+08. In the year 1980, what is the difference between the Amount (in current US$) in Dominican Republic and Amount (in current US$) in Panama?
Make the answer very short. 1.60e+08. In the year 1980, what is the difference between the Amount (in current US$) of Ethiopia and Amount (in current US$) of Panama?
Your answer should be compact. -9.63e+07. In the year 1981, what is the difference between the Amount (in current US$) of Sub-Saharan Africa (developing only) and Amount (in current US$) of Dominican Republic?
Your response must be concise. 8.17e+09. In the year 1981, what is the difference between the Amount (in current US$) in Sub-Saharan Africa (developing only) and Amount (in current US$) in Ethiopia?
Provide a short and direct response. 7.38e+09. In the year 1981, what is the difference between the Amount (in current US$) in Sub-Saharan Africa (developing only) and Amount (in current US$) in Panama?
Provide a succinct answer. 8.17e+09. In the year 1981, what is the difference between the Amount (in current US$) of Dominican Republic and Amount (in current US$) of Ethiopia?
Ensure brevity in your answer.  -7.96e+08. In the year 1981, what is the difference between the Amount (in current US$) in Dominican Republic and Amount (in current US$) in Panama?
Your answer should be very brief. -4.19e+06. In the year 1981, what is the difference between the Amount (in current US$) in Ethiopia and Amount (in current US$) in Panama?
Provide a succinct answer. 7.92e+08. In the year 1982, what is the difference between the Amount (in current US$) of Sub-Saharan Africa (developing only) and Amount (in current US$) of Dominican Republic?
Ensure brevity in your answer.  9.85e+09. In the year 1982, what is the difference between the Amount (in current US$) of Sub-Saharan Africa (developing only) and Amount (in current US$) of Ethiopia?
Your response must be concise. 8.68e+09. In the year 1982, what is the difference between the Amount (in current US$) in Sub-Saharan Africa (developing only) and Amount (in current US$) in Panama?
Give a very brief answer. 9.63e+09. In the year 1982, what is the difference between the Amount (in current US$) of Dominican Republic and Amount (in current US$) of Ethiopia?
Your response must be concise. -1.17e+09. In the year 1982, what is the difference between the Amount (in current US$) of Dominican Republic and Amount (in current US$) of Panama?
Give a very brief answer. -2.19e+08. In the year 1982, what is the difference between the Amount (in current US$) in Ethiopia and Amount (in current US$) in Panama?
Your response must be concise. 9.50e+08. In the year 1983, what is the difference between the Amount (in current US$) of Sub-Saharan Africa (developing only) and Amount (in current US$) of Dominican Republic?
Provide a short and direct response. 7.59e+09. In the year 1983, what is the difference between the Amount (in current US$) in Sub-Saharan Africa (developing only) and Amount (in current US$) in Ethiopia?
Your answer should be very brief. 6.83e+09. In the year 1983, what is the difference between the Amount (in current US$) of Sub-Saharan Africa (developing only) and Amount (in current US$) of Panama?
Provide a succinct answer. 7.42e+09. In the year 1983, what is the difference between the Amount (in current US$) in Dominican Republic and Amount (in current US$) in Ethiopia?
Give a very brief answer. -7.55e+08. In the year 1983, what is the difference between the Amount (in current US$) in Dominican Republic and Amount (in current US$) in Panama?
Ensure brevity in your answer.  -1.63e+08. In the year 1983, what is the difference between the Amount (in current US$) in Ethiopia and Amount (in current US$) in Panama?
Make the answer very short. 5.92e+08. In the year 1984, what is the difference between the Amount (in current US$) of Sub-Saharan Africa (developing only) and Amount (in current US$) of Dominican Republic?
Your answer should be compact. 4.99e+09. In the year 1984, what is the difference between the Amount (in current US$) in Sub-Saharan Africa (developing only) and Amount (in current US$) in Ethiopia?
Offer a terse response. 4.58e+09. In the year 1984, what is the difference between the Amount (in current US$) in Sub-Saharan Africa (developing only) and Amount (in current US$) in Panama?
Provide a short and direct response. 5.04e+09. In the year 1984, what is the difference between the Amount (in current US$) of Dominican Republic and Amount (in current US$) of Ethiopia?
Keep it short and to the point. -4.13e+08. In the year 1984, what is the difference between the Amount (in current US$) of Dominican Republic and Amount (in current US$) of Panama?
Your answer should be compact. 5.21e+07. In the year 1984, what is the difference between the Amount (in current US$) of Ethiopia and Amount (in current US$) of Panama?
Offer a terse response. 4.65e+08. In the year 1985, what is the difference between the Amount (in current US$) in Sub-Saharan Africa (developing only) and Amount (in current US$) in Dominican Republic?
Keep it short and to the point. 3.31e+09. In the year 1985, what is the difference between the Amount (in current US$) in Sub-Saharan Africa (developing only) and Amount (in current US$) in Ethiopia?
Provide a succinct answer. 2.89e+09. In the year 1985, what is the difference between the Amount (in current US$) of Sub-Saharan Africa (developing only) and Amount (in current US$) of Panama?
Your response must be concise. 3.41e+09. In the year 1985, what is the difference between the Amount (in current US$) of Dominican Republic and Amount (in current US$) of Ethiopia?
Offer a terse response. -4.26e+08. In the year 1985, what is the difference between the Amount (in current US$) of Dominican Republic and Amount (in current US$) of Panama?
Provide a succinct answer. 1.02e+08. In the year 1985, what is the difference between the Amount (in current US$) in Ethiopia and Amount (in current US$) in Panama?
Give a very brief answer. 5.27e+08. In the year 1986, what is the difference between the Amount (in current US$) of Sub-Saharan Africa (developing only) and Amount (in current US$) of Dominican Republic?
Provide a short and direct response. 5.42e+09. In the year 1986, what is the difference between the Amount (in current US$) in Sub-Saharan Africa (developing only) and Amount (in current US$) in Ethiopia?
Make the answer very short. 5.09e+09. In the year 1986, what is the difference between the Amount (in current US$) in Sub-Saharan Africa (developing only) and Amount (in current US$) in Panama?
Ensure brevity in your answer.  5.42e+09. In the year 1986, what is the difference between the Amount (in current US$) in Dominican Republic and Amount (in current US$) in Ethiopia?
Offer a terse response. -3.25e+08. In the year 1986, what is the difference between the Amount (in current US$) of Dominican Republic and Amount (in current US$) of Panama?
Your answer should be compact. 5.48e+06. In the year 1986, what is the difference between the Amount (in current US$) of Ethiopia and Amount (in current US$) of Panama?
Ensure brevity in your answer.  3.31e+08. What is the ratio of the Amount (in current US$) of Sub-Saharan Africa (developing only) in 1979 to that in 1980?
Your answer should be very brief. 0.86. What is the ratio of the Amount (in current US$) in Dominican Republic in 1979 to that in 1980?
Offer a very short reply. 0.38. What is the ratio of the Amount (in current US$) of Ethiopia in 1979 to that in 1980?
Provide a succinct answer. 1.09. What is the ratio of the Amount (in current US$) of Panama in 1979 to that in 1980?
Make the answer very short. 1.16. What is the ratio of the Amount (in current US$) of Sub-Saharan Africa (developing only) in 1979 to that in 1981?
Offer a very short reply. 0.8. What is the ratio of the Amount (in current US$) in Dominican Republic in 1979 to that in 1981?
Provide a short and direct response. 0.81. What is the ratio of the Amount (in current US$) of Ethiopia in 1979 to that in 1981?
Keep it short and to the point. 0.11. What is the ratio of the Amount (in current US$) of Panama in 1979 to that in 1981?
Your answer should be compact. 1.33. What is the ratio of the Amount (in current US$) in Sub-Saharan Africa (developing only) in 1979 to that in 1982?
Provide a short and direct response. 0.66. What is the ratio of the Amount (in current US$) of Dominican Republic in 1979 to that in 1982?
Your answer should be very brief. 0.48. What is the ratio of the Amount (in current US$) of Ethiopia in 1979 to that in 1982?
Give a very brief answer. 0.07. What is the ratio of the Amount (in current US$) in Panama in 1979 to that in 1982?
Keep it short and to the point. 0.44. What is the ratio of the Amount (in current US$) in Sub-Saharan Africa (developing only) in 1979 to that in 1983?
Keep it short and to the point. 0.87. What is the ratio of the Amount (in current US$) in Dominican Republic in 1979 to that in 1983?
Offer a terse response. 1.94. What is the ratio of the Amount (in current US$) of Ethiopia in 1979 to that in 1983?
Offer a terse response. 0.12. What is the ratio of the Amount (in current US$) of Panama in 1979 to that in 1983?
Make the answer very short. 0.95. What is the ratio of the Amount (in current US$) of Sub-Saharan Africa (developing only) in 1979 to that in 1984?
Give a very brief answer. 1.28. What is the ratio of the Amount (in current US$) in Dominican Republic in 1979 to that in 1984?
Give a very brief answer. 0.61. What is the ratio of the Amount (in current US$) of Ethiopia in 1979 to that in 1984?
Make the answer very short. 0.16. What is the ratio of the Amount (in current US$) in Panama in 1979 to that in 1984?
Your response must be concise. 1.34. What is the ratio of the Amount (in current US$) in Sub-Saharan Africa (developing only) in 1979 to that in 1985?
Keep it short and to the point. 1.91. What is the ratio of the Amount (in current US$) of Dominican Republic in 1979 to that in 1985?
Offer a terse response. 0.8. What is the ratio of the Amount (in current US$) of Ethiopia in 1979 to that in 1985?
Make the answer very short. 0.17. What is the ratio of the Amount (in current US$) of Panama in 1979 to that in 1985?
Ensure brevity in your answer.  3.48. What is the ratio of the Amount (in current US$) of Sub-Saharan Africa (developing only) in 1979 to that in 1986?
Give a very brief answer. 1.2. What is the ratio of the Amount (in current US$) of Dominican Republic in 1979 to that in 1986?
Offer a very short reply. 1.35. What is the ratio of the Amount (in current US$) in Ethiopia in 1979 to that in 1986?
Provide a short and direct response. 0.24. What is the ratio of the Amount (in current US$) of Panama in 1979 to that in 1986?
Provide a short and direct response. 2.39. What is the ratio of the Amount (in current US$) in Sub-Saharan Africa (developing only) in 1980 to that in 1981?
Your answer should be very brief. 0.93. What is the ratio of the Amount (in current US$) in Dominican Republic in 1980 to that in 1981?
Your response must be concise. 2.17. What is the ratio of the Amount (in current US$) in Ethiopia in 1980 to that in 1981?
Keep it short and to the point. 0.1. What is the ratio of the Amount (in current US$) of Panama in 1980 to that in 1981?
Offer a very short reply. 1.14. What is the ratio of the Amount (in current US$) of Sub-Saharan Africa (developing only) in 1980 to that in 1982?
Keep it short and to the point. 0.76. What is the ratio of the Amount (in current US$) of Dominican Republic in 1980 to that in 1982?
Make the answer very short. 1.27. What is the ratio of the Amount (in current US$) of Ethiopia in 1980 to that in 1982?
Your answer should be compact. 0.06. What is the ratio of the Amount (in current US$) in Panama in 1980 to that in 1982?
Your answer should be compact. 0.38. What is the ratio of the Amount (in current US$) of Sub-Saharan Africa (developing only) in 1980 to that in 1983?
Keep it short and to the point. 1.01. What is the ratio of the Amount (in current US$) in Dominican Republic in 1980 to that in 1983?
Offer a terse response. 5.16. What is the ratio of the Amount (in current US$) of Ethiopia in 1980 to that in 1983?
Your answer should be compact. 0.11. What is the ratio of the Amount (in current US$) of Panama in 1980 to that in 1983?
Provide a short and direct response. 0.82. What is the ratio of the Amount (in current US$) in Sub-Saharan Africa (developing only) in 1980 to that in 1984?
Your answer should be very brief. 1.49. What is the ratio of the Amount (in current US$) of Dominican Republic in 1980 to that in 1984?
Ensure brevity in your answer.  1.62. What is the ratio of the Amount (in current US$) in Ethiopia in 1980 to that in 1984?
Offer a terse response. 0.15. What is the ratio of the Amount (in current US$) in Panama in 1980 to that in 1984?
Provide a succinct answer. 1.15. What is the ratio of the Amount (in current US$) in Sub-Saharan Africa (developing only) in 1980 to that in 1985?
Give a very brief answer. 2.23. What is the ratio of the Amount (in current US$) in Dominican Republic in 1980 to that in 1985?
Provide a short and direct response. 2.12. What is the ratio of the Amount (in current US$) of Ethiopia in 1980 to that in 1985?
Your response must be concise. 0.16. What is the ratio of the Amount (in current US$) in Panama in 1980 to that in 1985?
Provide a succinct answer. 3. What is the ratio of the Amount (in current US$) of Sub-Saharan Africa (developing only) in 1980 to that in 1986?
Your answer should be compact. 1.4. What is the ratio of the Amount (in current US$) in Dominican Republic in 1980 to that in 1986?
Provide a succinct answer. 3.6. What is the ratio of the Amount (in current US$) in Ethiopia in 1980 to that in 1986?
Offer a very short reply. 0.22. What is the ratio of the Amount (in current US$) of Panama in 1980 to that in 1986?
Your response must be concise. 2.07. What is the ratio of the Amount (in current US$) in Sub-Saharan Africa (developing only) in 1981 to that in 1982?
Give a very brief answer. 0.82. What is the ratio of the Amount (in current US$) in Dominican Republic in 1981 to that in 1982?
Keep it short and to the point. 0.59. What is the ratio of the Amount (in current US$) in Ethiopia in 1981 to that in 1982?
Give a very brief answer. 0.66. What is the ratio of the Amount (in current US$) in Panama in 1981 to that in 1982?
Your response must be concise. 0.34. What is the ratio of the Amount (in current US$) of Sub-Saharan Africa (developing only) in 1981 to that in 1983?
Give a very brief answer. 1.09. What is the ratio of the Amount (in current US$) in Dominican Republic in 1981 to that in 1983?
Ensure brevity in your answer.  2.38. What is the ratio of the Amount (in current US$) of Ethiopia in 1981 to that in 1983?
Give a very brief answer. 1.16. What is the ratio of the Amount (in current US$) of Panama in 1981 to that in 1983?
Your answer should be very brief. 0.72. What is the ratio of the Amount (in current US$) of Sub-Saharan Africa (developing only) in 1981 to that in 1984?
Keep it short and to the point. 1.6. What is the ratio of the Amount (in current US$) of Dominican Republic in 1981 to that in 1984?
Make the answer very short. 0.75. What is the ratio of the Amount (in current US$) of Ethiopia in 1981 to that in 1984?
Provide a succinct answer. 1.52. What is the ratio of the Amount (in current US$) in Panama in 1981 to that in 1984?
Provide a short and direct response. 1.01. What is the ratio of the Amount (in current US$) in Sub-Saharan Africa (developing only) in 1981 to that in 1985?
Your answer should be very brief. 2.4. What is the ratio of the Amount (in current US$) of Dominican Republic in 1981 to that in 1985?
Provide a short and direct response. 0.98. What is the ratio of the Amount (in current US$) in Ethiopia in 1981 to that in 1985?
Ensure brevity in your answer.  1.62. What is the ratio of the Amount (in current US$) in Panama in 1981 to that in 1985?
Your response must be concise. 2.62. What is the ratio of the Amount (in current US$) of Sub-Saharan Africa (developing only) in 1981 to that in 1986?
Your answer should be very brief. 1.51. What is the ratio of the Amount (in current US$) of Dominican Republic in 1981 to that in 1986?
Provide a succinct answer. 1.66. What is the ratio of the Amount (in current US$) of Ethiopia in 1981 to that in 1986?
Offer a very short reply. 2.27. What is the ratio of the Amount (in current US$) of Panama in 1981 to that in 1986?
Provide a short and direct response. 1.8. What is the ratio of the Amount (in current US$) of Sub-Saharan Africa (developing only) in 1982 to that in 1983?
Provide a succinct answer. 1.32. What is the ratio of the Amount (in current US$) in Dominican Republic in 1982 to that in 1983?
Give a very brief answer. 4.05. What is the ratio of the Amount (in current US$) of Ethiopia in 1982 to that in 1983?
Your answer should be very brief. 1.75. What is the ratio of the Amount (in current US$) of Panama in 1982 to that in 1983?
Make the answer very short. 2.14. What is the ratio of the Amount (in current US$) of Sub-Saharan Africa (developing only) in 1982 to that in 1984?
Make the answer very short. 1.94. What is the ratio of the Amount (in current US$) of Dominican Republic in 1982 to that in 1984?
Keep it short and to the point. 1.27. What is the ratio of the Amount (in current US$) of Ethiopia in 1982 to that in 1984?
Keep it short and to the point. 2.3. What is the ratio of the Amount (in current US$) in Panama in 1982 to that in 1984?
Offer a terse response. 3.01. What is the ratio of the Amount (in current US$) of Sub-Saharan Africa (developing only) in 1982 to that in 1985?
Give a very brief answer. 2.91. What is the ratio of the Amount (in current US$) of Dominican Republic in 1982 to that in 1985?
Provide a succinct answer. 1.66. What is the ratio of the Amount (in current US$) in Ethiopia in 1982 to that in 1985?
Your response must be concise. 2.44. What is the ratio of the Amount (in current US$) in Panama in 1982 to that in 1985?
Provide a short and direct response. 7.82. What is the ratio of the Amount (in current US$) in Sub-Saharan Africa (developing only) in 1982 to that in 1986?
Keep it short and to the point. 1.84. What is the ratio of the Amount (in current US$) of Dominican Republic in 1982 to that in 1986?
Offer a terse response. 2.82. What is the ratio of the Amount (in current US$) of Ethiopia in 1982 to that in 1986?
Your response must be concise. 3.42. What is the ratio of the Amount (in current US$) in Panama in 1982 to that in 1986?
Provide a succinct answer. 5.38. What is the ratio of the Amount (in current US$) in Sub-Saharan Africa (developing only) in 1983 to that in 1984?
Make the answer very short. 1.47. What is the ratio of the Amount (in current US$) in Dominican Republic in 1983 to that in 1984?
Make the answer very short. 0.31. What is the ratio of the Amount (in current US$) in Ethiopia in 1983 to that in 1984?
Offer a terse response. 1.31. What is the ratio of the Amount (in current US$) in Panama in 1983 to that in 1984?
Ensure brevity in your answer.  1.41. What is the ratio of the Amount (in current US$) of Sub-Saharan Africa (developing only) in 1983 to that in 1985?
Offer a terse response. 2.2. What is the ratio of the Amount (in current US$) of Dominican Republic in 1983 to that in 1985?
Keep it short and to the point. 0.41. What is the ratio of the Amount (in current US$) in Ethiopia in 1983 to that in 1985?
Your response must be concise. 1.39. What is the ratio of the Amount (in current US$) in Panama in 1983 to that in 1985?
Keep it short and to the point. 3.66. What is the ratio of the Amount (in current US$) in Sub-Saharan Africa (developing only) in 1983 to that in 1986?
Give a very brief answer. 1.39. What is the ratio of the Amount (in current US$) of Dominican Republic in 1983 to that in 1986?
Your answer should be very brief. 0.7. What is the ratio of the Amount (in current US$) in Ethiopia in 1983 to that in 1986?
Your response must be concise. 1.95. What is the ratio of the Amount (in current US$) in Panama in 1983 to that in 1986?
Ensure brevity in your answer.  2.52. What is the ratio of the Amount (in current US$) of Sub-Saharan Africa (developing only) in 1984 to that in 1985?
Your answer should be compact. 1.5. What is the ratio of the Amount (in current US$) of Dominican Republic in 1984 to that in 1985?
Make the answer very short. 1.31. What is the ratio of the Amount (in current US$) in Ethiopia in 1984 to that in 1985?
Your answer should be very brief. 1.06. What is the ratio of the Amount (in current US$) of Panama in 1984 to that in 1985?
Offer a terse response. 2.6. What is the ratio of the Amount (in current US$) of Sub-Saharan Africa (developing only) in 1984 to that in 1986?
Your answer should be very brief. 0.94. What is the ratio of the Amount (in current US$) of Dominican Republic in 1984 to that in 1986?
Your answer should be compact. 2.22. What is the ratio of the Amount (in current US$) in Ethiopia in 1984 to that in 1986?
Offer a terse response. 1.49. What is the ratio of the Amount (in current US$) of Panama in 1984 to that in 1986?
Provide a succinct answer. 1.79. What is the ratio of the Amount (in current US$) of Sub-Saharan Africa (developing only) in 1985 to that in 1986?
Your response must be concise. 0.63. What is the ratio of the Amount (in current US$) in Dominican Republic in 1985 to that in 1986?
Your response must be concise. 1.7. What is the ratio of the Amount (in current US$) of Ethiopia in 1985 to that in 1986?
Offer a terse response. 1.4. What is the ratio of the Amount (in current US$) in Panama in 1985 to that in 1986?
Ensure brevity in your answer.  0.69. What is the difference between the highest and the second highest Amount (in current US$) of Sub-Saharan Africa (developing only)?
Your answer should be very brief. 1.79e+09. What is the difference between the highest and the second highest Amount (in current US$) of Dominican Republic?
Offer a very short reply. 7.50e+07. What is the difference between the highest and the second highest Amount (in current US$) of Ethiopia?
Keep it short and to the point. 4.86e+08. What is the difference between the highest and the second highest Amount (in current US$) of Panama?
Make the answer very short. 2.62e+08. What is the difference between the highest and the lowest Amount (in current US$) in Sub-Saharan Africa (developing only)?
Your response must be concise. 6.64e+09. What is the difference between the highest and the lowest Amount (in current US$) in Dominican Republic?
Your answer should be very brief. 2.82e+08. What is the difference between the highest and the lowest Amount (in current US$) in Ethiopia?
Provide a short and direct response. 1.35e+09. What is the difference between the highest and the lowest Amount (in current US$) of Panama?
Your answer should be very brief. 4.30e+08. 